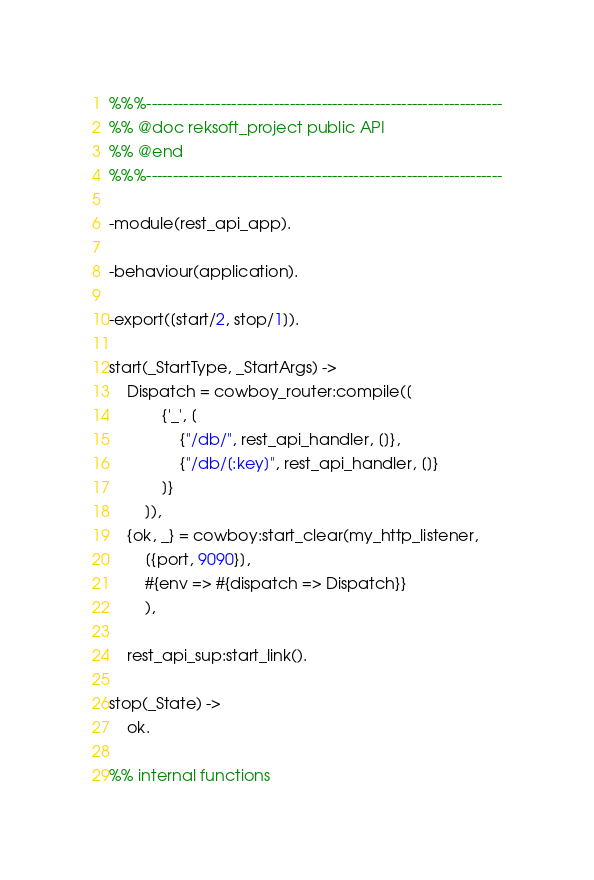Convert code to text. <code><loc_0><loc_0><loc_500><loc_500><_Erlang_>%%%-------------------------------------------------------------------
%% @doc reksoft_project public API
%% @end
%%%-------------------------------------------------------------------

-module(rest_api_app).

-behaviour(application).

-export([start/2, stop/1]).

start(_StartType, _StartArgs) ->
    Dispatch = cowboy_router:compile([
            {'_', [
                {"/db/", rest_api_handler, []},
                {"/db/[:key]", rest_api_handler, []}
            ]}
        ]),
    {ok, _} = cowboy:start_clear(my_http_listener,
        [{port, 9090}],
        #{env => #{dispatch => Dispatch}}
        ),

    rest_api_sup:start_link().

stop(_State) ->
    ok.

%% internal functions</code> 